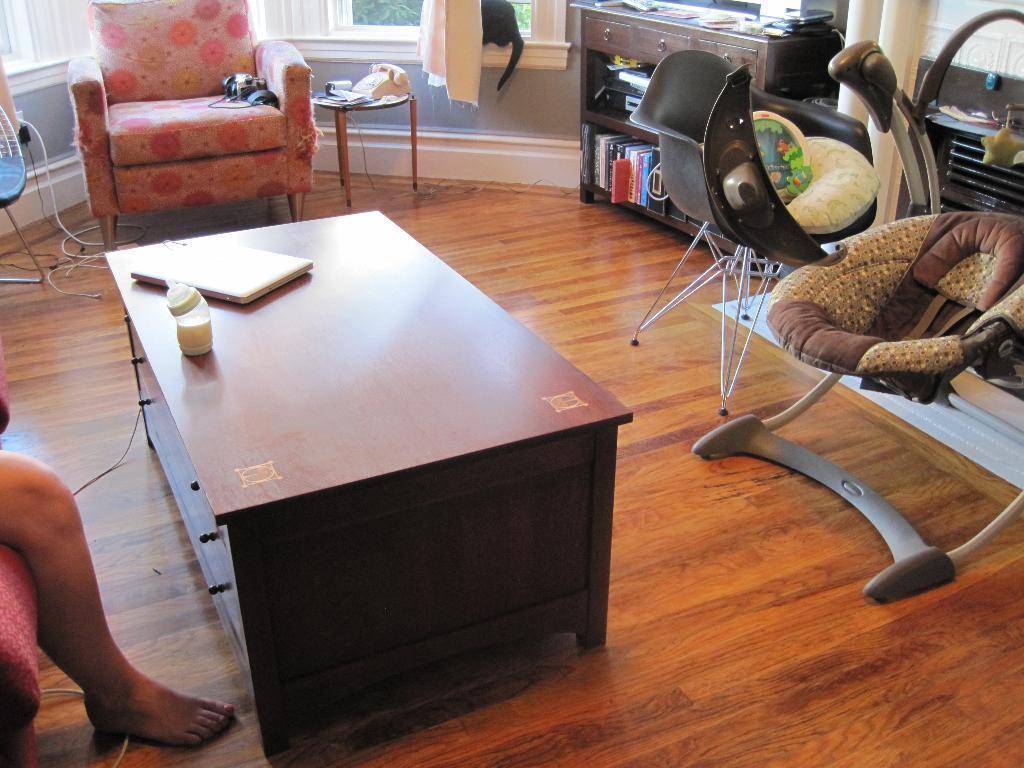Can you describe this image briefly? This picture might be taken inside the room. In this image, on the right side, we can see leg of a person. In the middle of the image, we can see a table, on that table, we can see a milk bottle and laptop. On the right side, we can see some chairs, table and a shelf with some book. In the background, we can see a couch and other table, on that table, we can see a mobile, cloth. In the background, we can also see a glass window. 